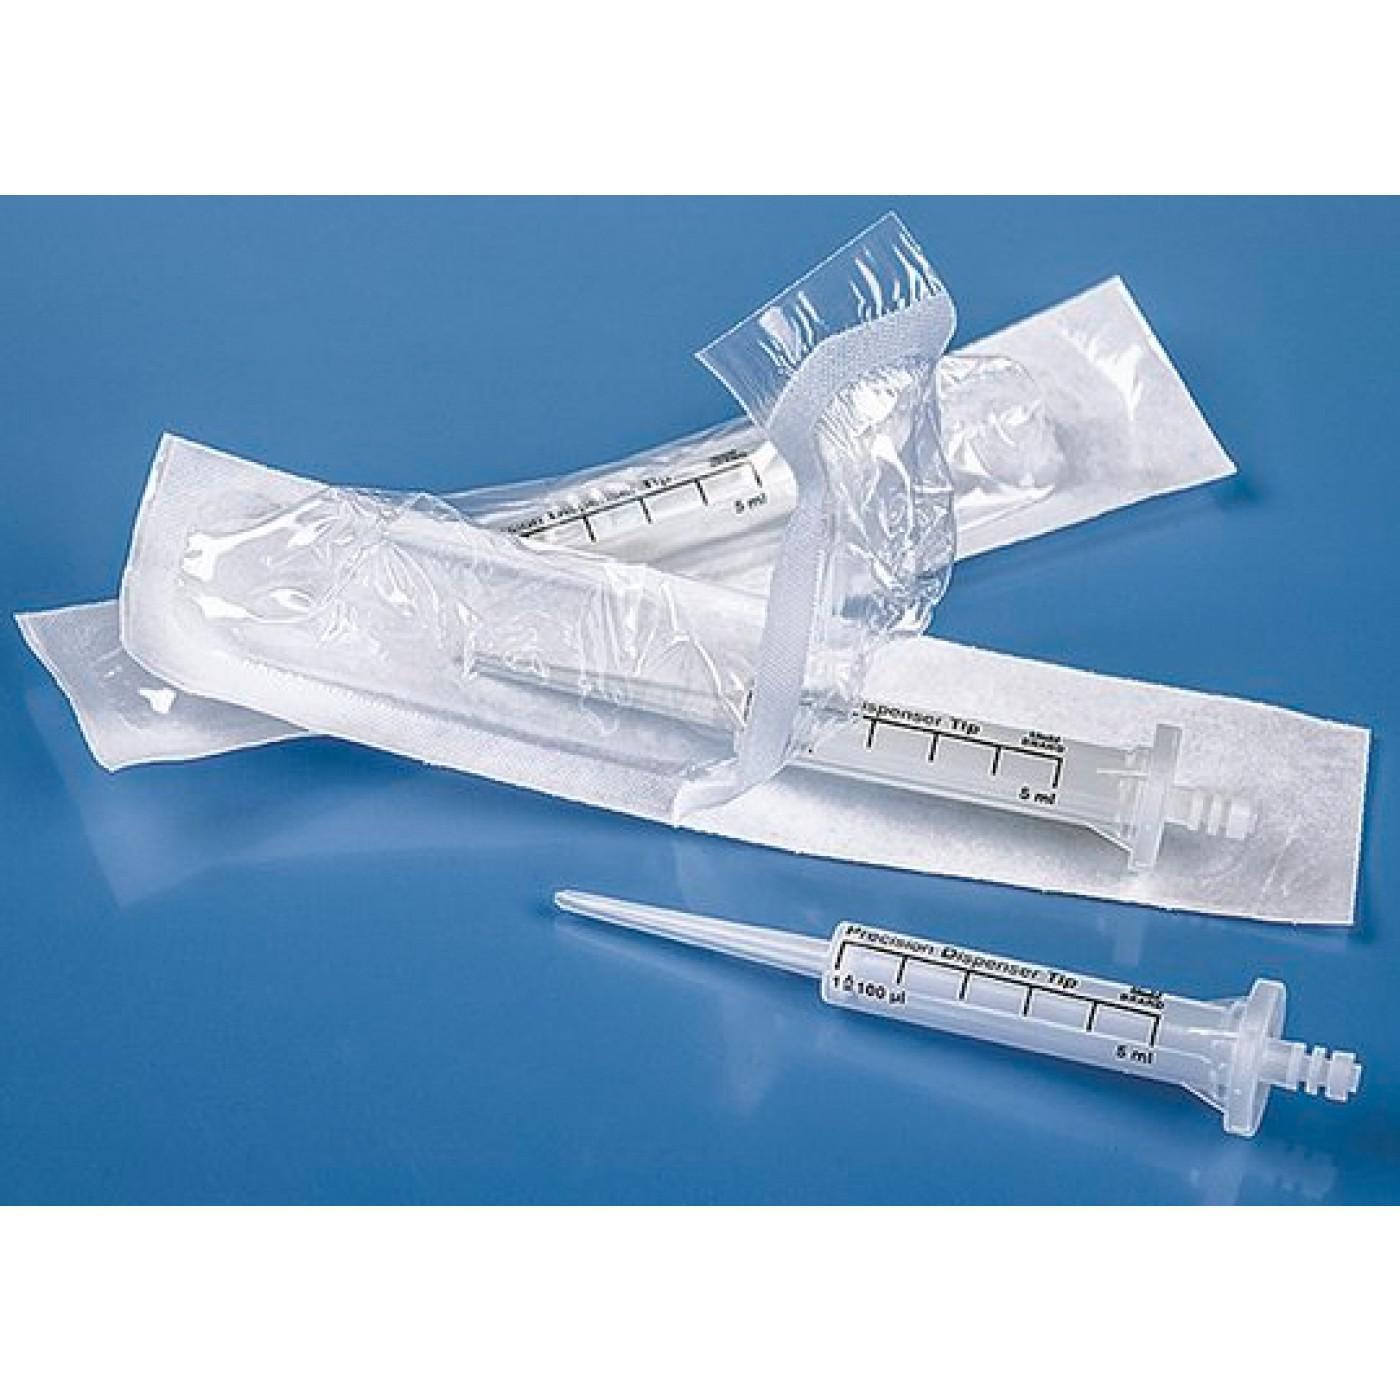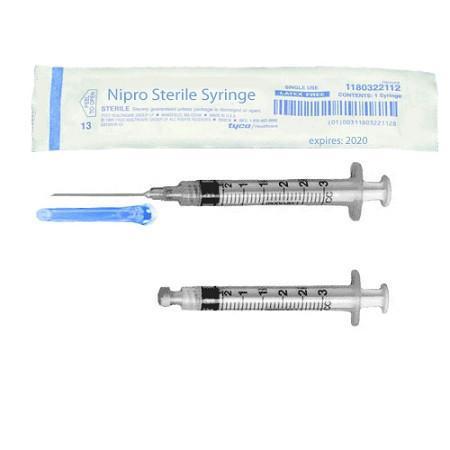The first image is the image on the left, the second image is the image on the right. Examine the images to the left and right. Is the description "There are exactly two syringes." accurate? Answer yes or no. No. 